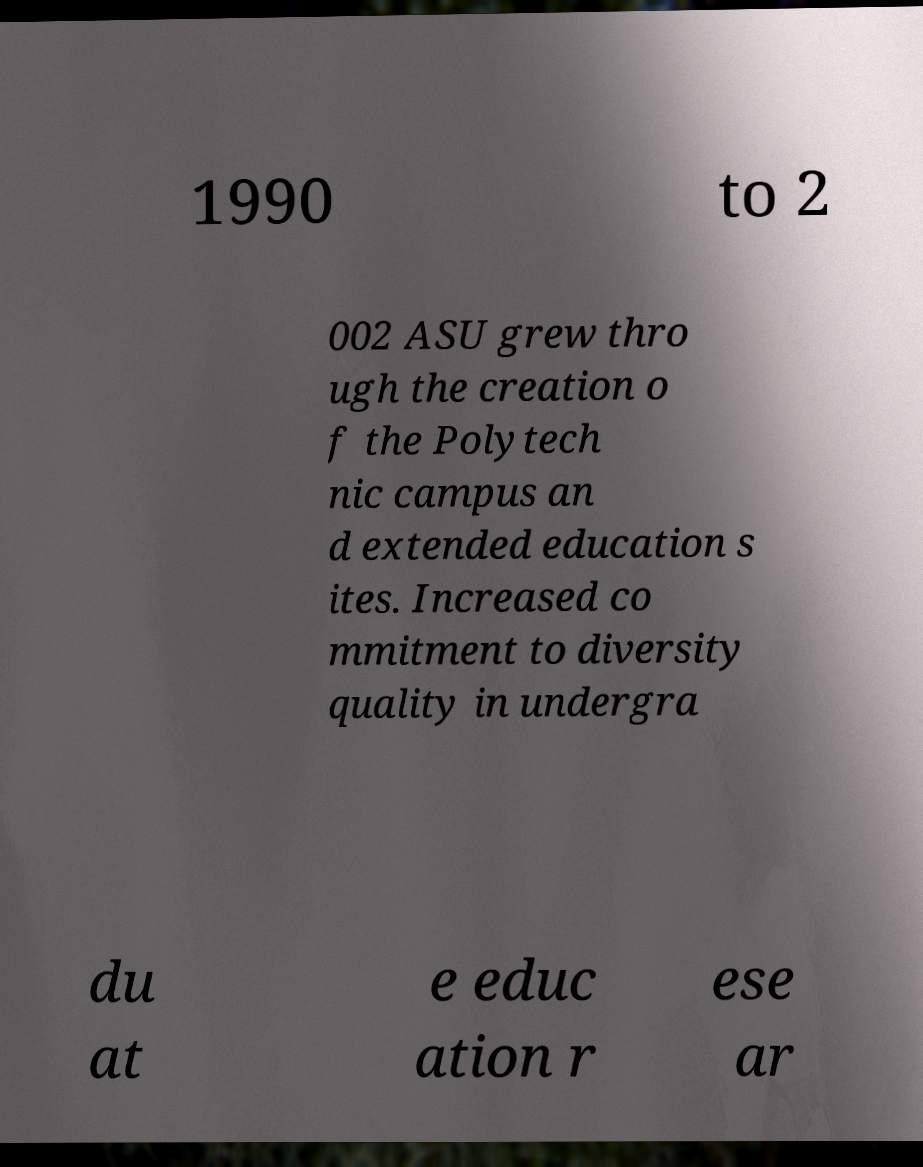Please read and relay the text visible in this image. What does it say? 1990 to 2 002 ASU grew thro ugh the creation o f the Polytech nic campus an d extended education s ites. Increased co mmitment to diversity quality in undergra du at e educ ation r ese ar 